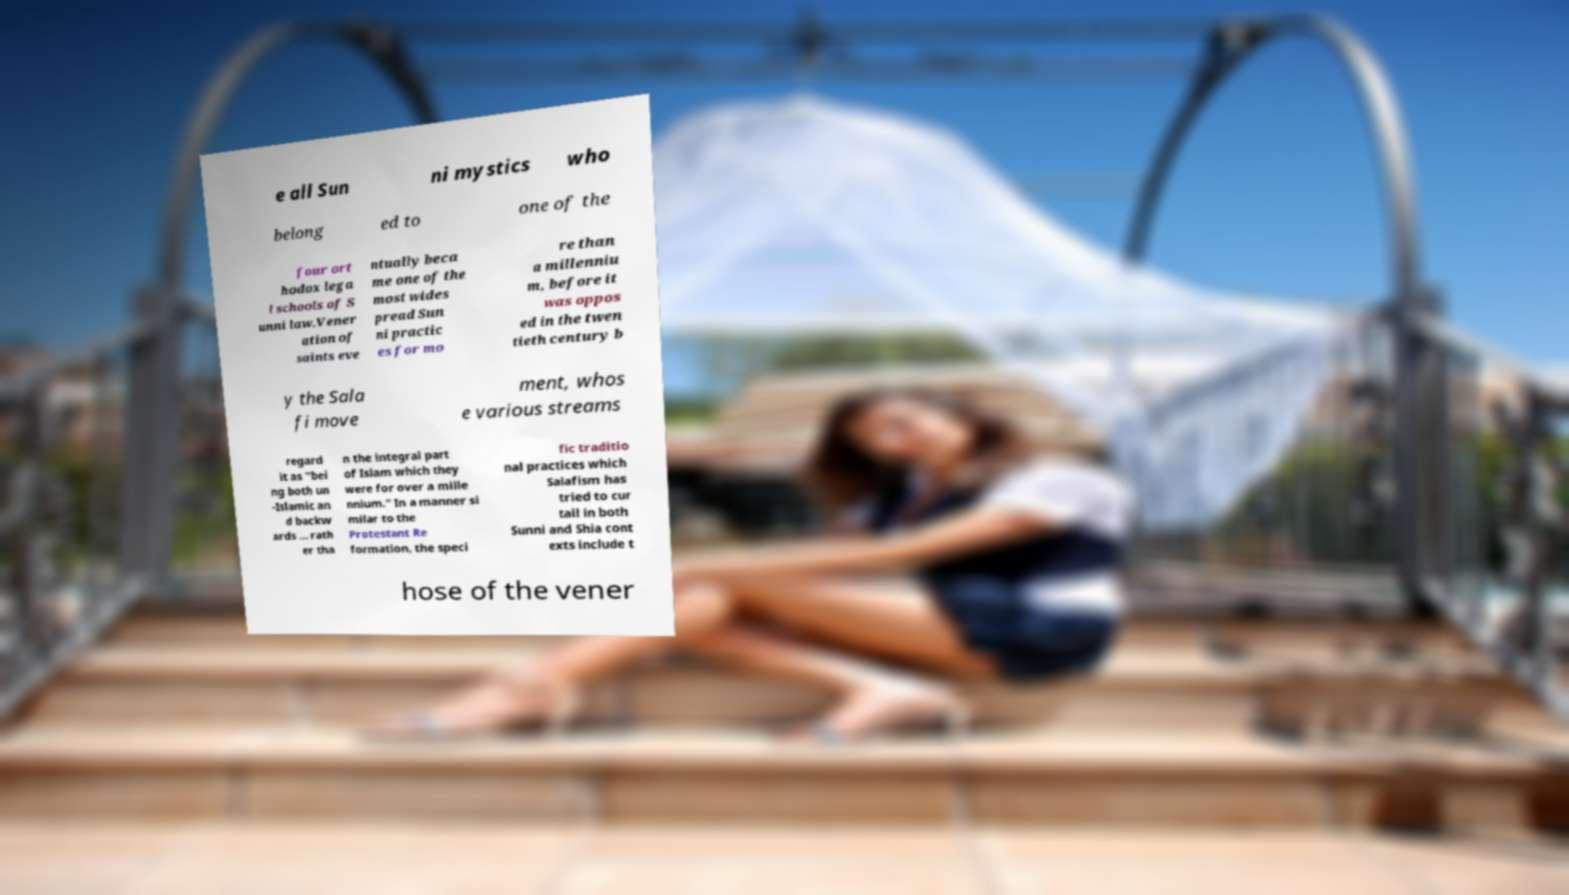I need the written content from this picture converted into text. Can you do that? e all Sun ni mystics who belong ed to one of the four ort hodox lega l schools of S unni law.Vener ation of saints eve ntually beca me one of the most wides pread Sun ni practic es for mo re than a millenniu m, before it was oppos ed in the twen tieth century b y the Sala fi move ment, whos e various streams regard it as "bei ng both un -Islamic an d backw ards ... rath er tha n the integral part of Islam which they were for over a mille nnium." In a manner si milar to the Protestant Re formation, the speci fic traditio nal practices which Salafism has tried to cur tail in both Sunni and Shia cont exts include t hose of the vener 